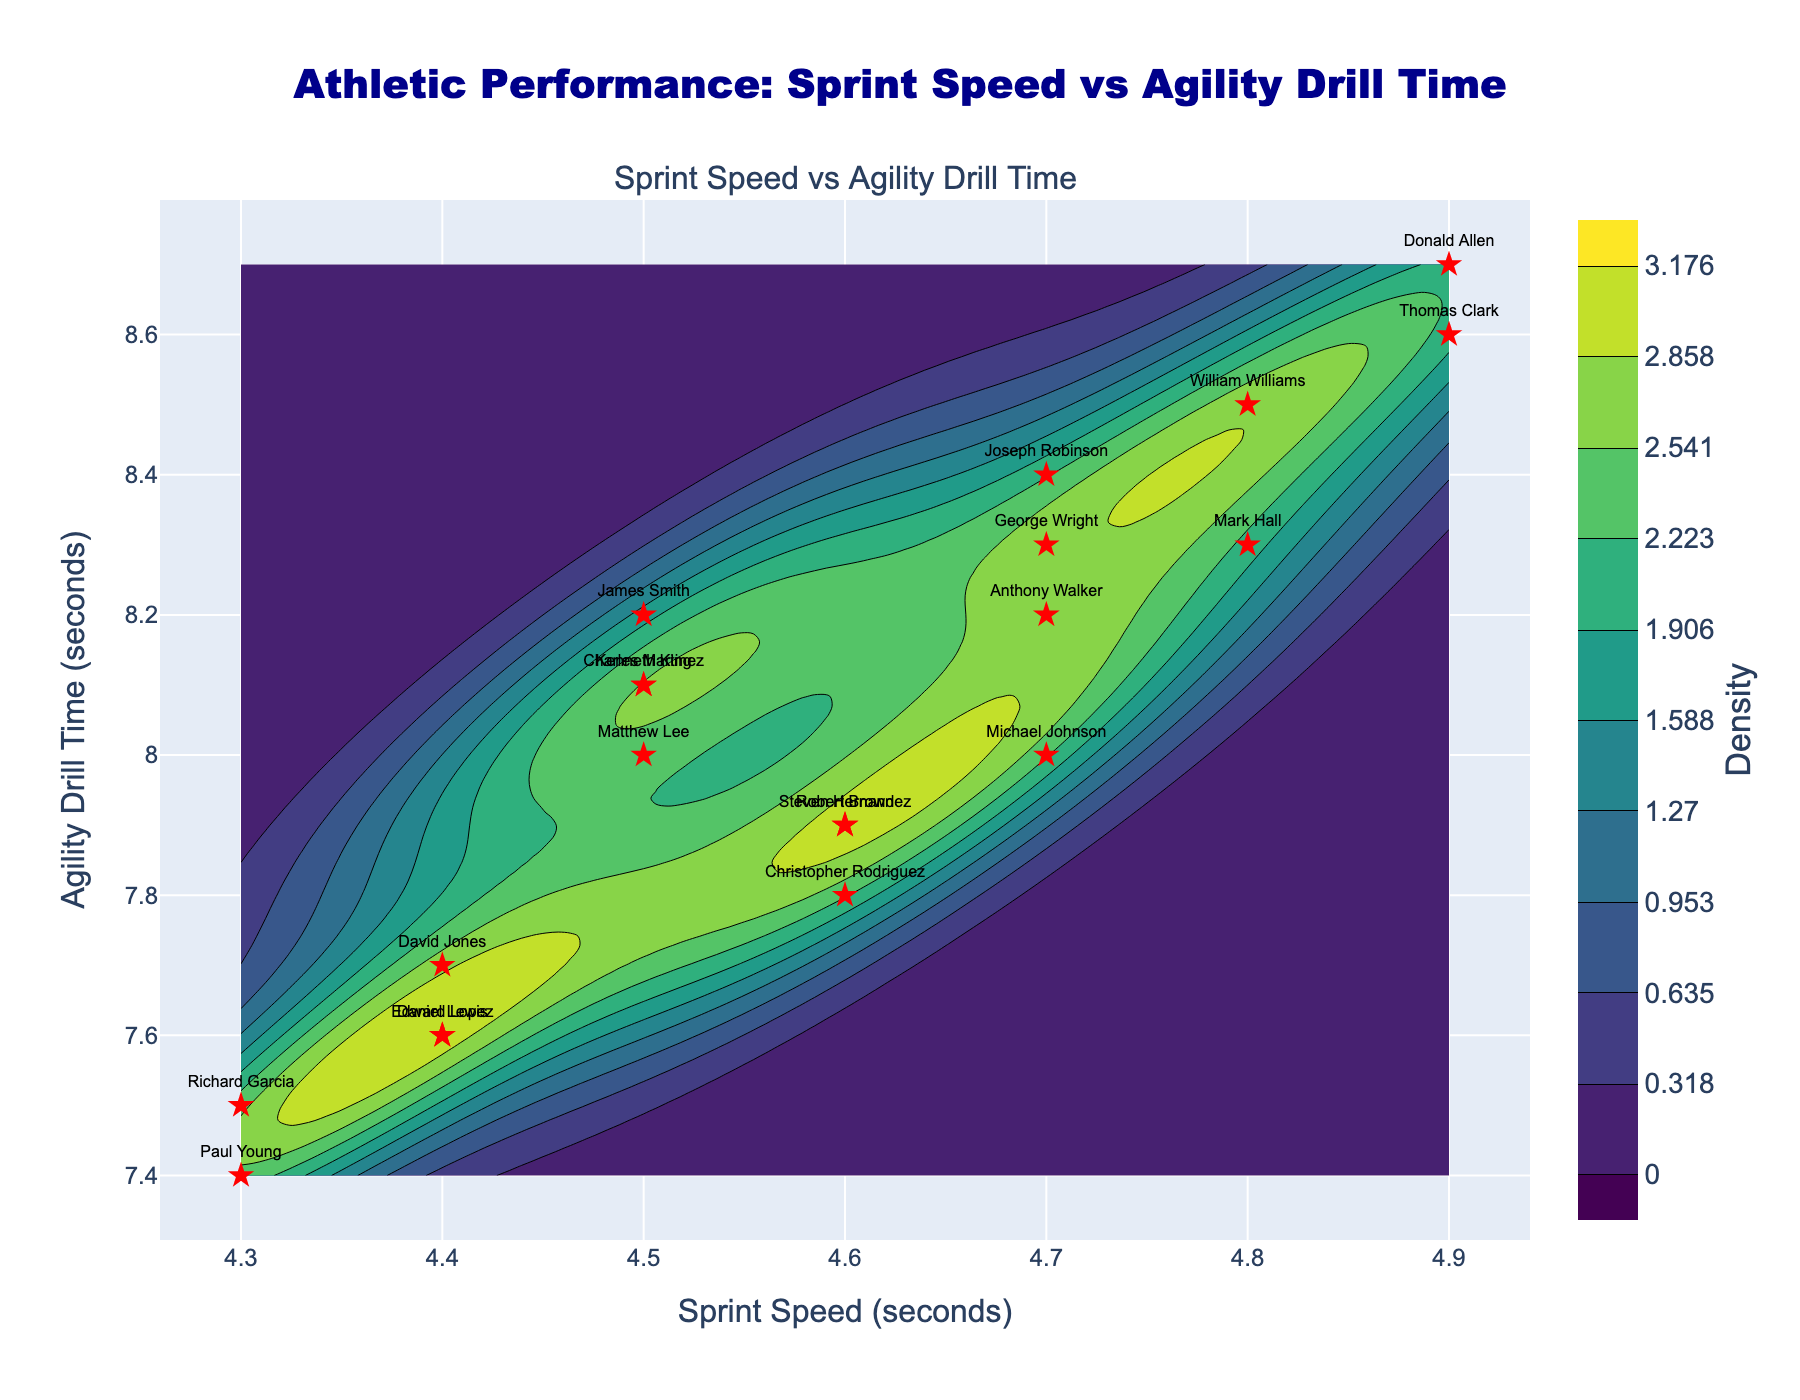What is the title of the plot? The title is displayed at the top of the plot and reads "Athletic Performance: Sprint Speed vs Agility Drill Time".
Answer: Athletic Performance: Sprint Speed vs Agility Drill Time How many data points are plotted in the scatter plot? By counting the number of markers representing players on the scatter plot, we can see there are 20 data points.
Answer: 20 What does the color in the contour plot represent? The color represents the density of data points. Darker colors correspond to areas with higher density as indicated by the color bar on the right side of the plot.
Answer: Density of data points What is the range of Sprint Speeds shown on the x-axis? The x-axis, labeled "Sprint Speed (seconds)", ranges from approximately 4.3 seconds to 4.9 seconds.
Answer: 4.3 to 4.9 seconds Who is the player with the fastest Sprint Speed and what is their speed? The fastest Sprint Speed is marked by the lowest x-axis value, which is 4.3 seconds, and from the scatter plot, we can see it is achieved by Richard Garcia and Paul Young.
Answer: Richard Garcia and Paul Young Which player has the slowest Agility Drill Time? The slowest Agility Drill Time is marked by the highest y-axis value, which is 8.7 seconds, and from the scatter plot, we can see it is achieved by Donald Allen.
Answer: Donald Allen What is the relationship between Sprint Speed and Agility Drill Time observed in the plot? The scatter plot and contour density show a negative correlation. As Sprint Speed (x-axis) decreases, Agility Drill Time (y-axis) tends to decrease as well.
Answer: Negative correlation On average, do players with Sprint Speeds below 4.5 seconds have faster Agility Drill Times compared to those above 4.5 seconds? By visually assessing where players with Sprint Speeds below and above 4.5 seconds fall along the Agility Drill Time axis, we see that players with Sprint Speeds below 4.5 seconds tend to have faster (lower) Agility Drill Times.
Answer: Yes Which region of the plot has the highest concentration of players? The highest concentration of players is where the color of the contour plot is darkest, located approximately around Sprint Speed of 4.5 to 4.7 seconds and Agility Drill Time of 8.0 to 8.3 seconds.
Answer: Around Sprint Speed 4.5-4.7 sec and Agility Drill Time 8.0-8.3 sec What is the Agility Drill Time for Charles Martinez and how does it compare to the average time? Charles Martinez has an Agility Drill Time of 8.1 seconds. This can be compared to the average Agility Drill Time by visually estimating the average of all y-axis values which appears around 8.0 seconds, making his time slightly above average.
Answer: 8.1 seconds (slightly above average) 